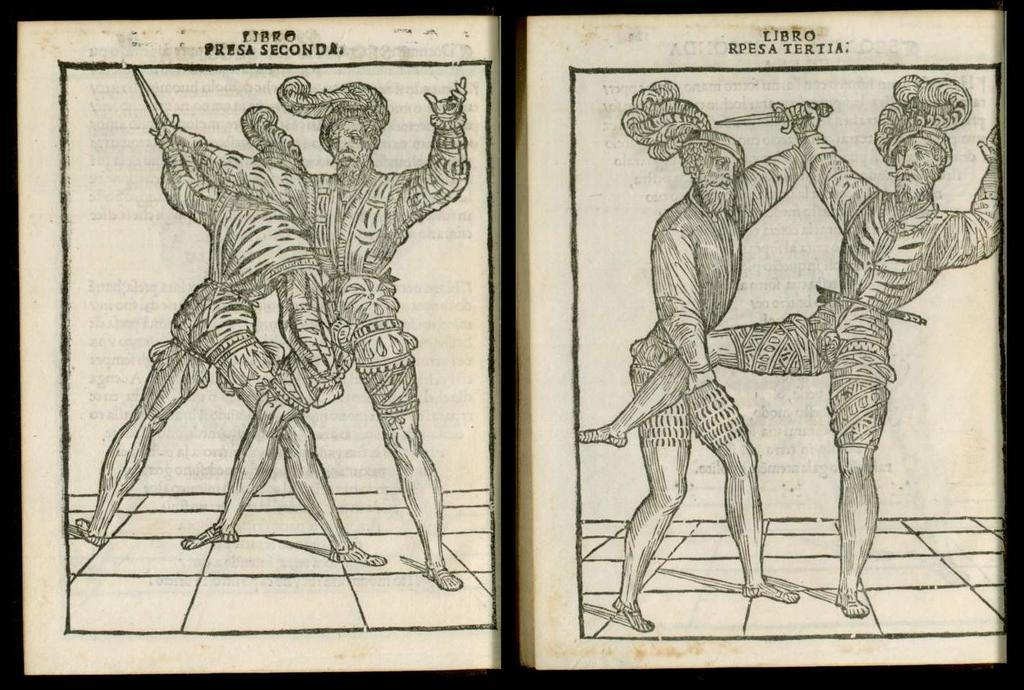What is present on the pages in the image? There are words and images of people on the pages in the image. Can you describe the content of the words on the pages? Unfortunately, the specific content of the words cannot be determined from the image alone. What type of images are depicted on the pages? The images on the pages depict people. What type of beetle can be seen crawling on the pages in the image? There is no beetle present on the pages in the image. What direction are the pages pointing in the image? The pages are not pointing in any specific direction in the image; they are simply visible. 